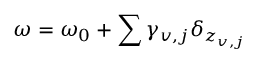Convert formula to latex. <formula><loc_0><loc_0><loc_500><loc_500>\omega = \omega _ { 0 } + \sum \gamma _ { v , j } \delta _ { z _ { v , j } }</formula> 